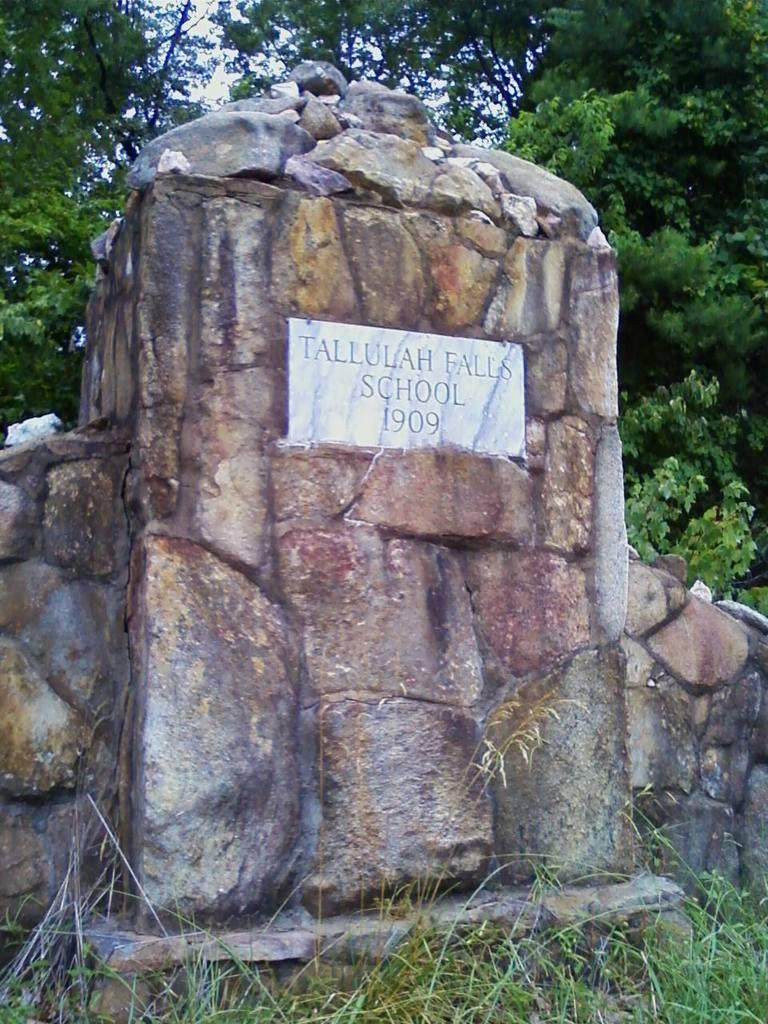What is the main subject in the center of the image? There is a headstone in the center of the image. What can be seen in the background of the image? There are trees in the background of the image. What type of field is being used for boating activities in the image? There is no field or boating activities present in the image; it features a headstone and trees. 